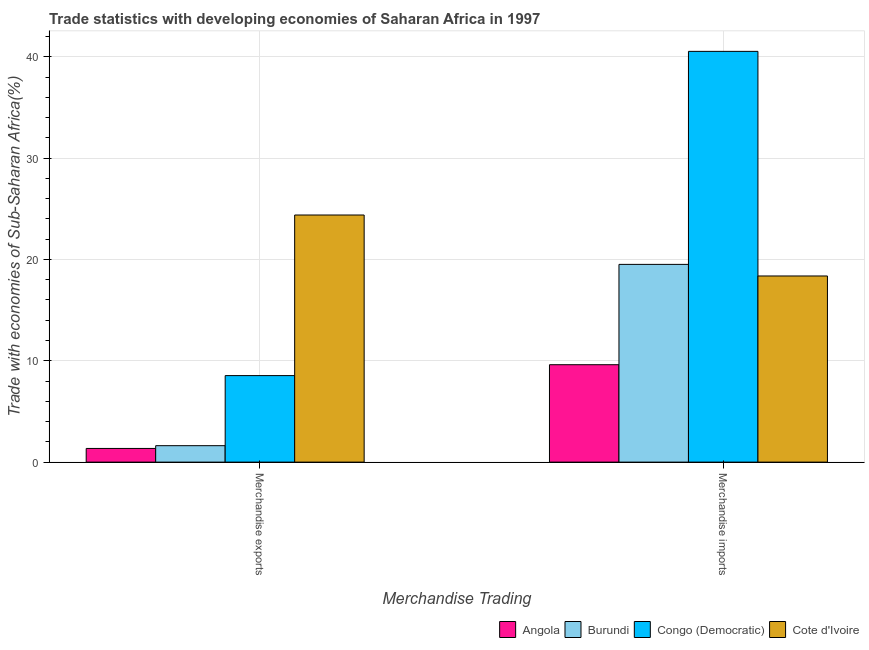How many different coloured bars are there?
Your answer should be very brief. 4. Are the number of bars per tick equal to the number of legend labels?
Make the answer very short. Yes. Are the number of bars on each tick of the X-axis equal?
Your response must be concise. Yes. What is the merchandise exports in Angola?
Offer a very short reply. 1.35. Across all countries, what is the maximum merchandise imports?
Provide a short and direct response. 40.53. Across all countries, what is the minimum merchandise exports?
Keep it short and to the point. 1.35. In which country was the merchandise imports maximum?
Provide a short and direct response. Congo (Democratic). In which country was the merchandise imports minimum?
Provide a succinct answer. Angola. What is the total merchandise imports in the graph?
Your answer should be compact. 88.02. What is the difference between the merchandise imports in Congo (Democratic) and that in Angola?
Offer a very short reply. 30.92. What is the difference between the merchandise exports in Cote d'Ivoire and the merchandise imports in Congo (Democratic)?
Make the answer very short. -16.15. What is the average merchandise exports per country?
Provide a short and direct response. 8.97. What is the difference between the merchandise imports and merchandise exports in Congo (Democratic)?
Keep it short and to the point. 31.99. In how many countries, is the merchandise exports greater than 28 %?
Keep it short and to the point. 0. What is the ratio of the merchandise imports in Congo (Democratic) to that in Angola?
Your answer should be very brief. 4.22. Is the merchandise imports in Congo (Democratic) less than that in Cote d'Ivoire?
Offer a terse response. No. In how many countries, is the merchandise imports greater than the average merchandise imports taken over all countries?
Offer a terse response. 1. What does the 2nd bar from the left in Merchandise exports represents?
Keep it short and to the point. Burundi. What does the 4th bar from the right in Merchandise imports represents?
Provide a succinct answer. Angola. How many bars are there?
Provide a short and direct response. 8. How many countries are there in the graph?
Your answer should be compact. 4. Does the graph contain any zero values?
Ensure brevity in your answer.  No. Does the graph contain grids?
Make the answer very short. Yes. What is the title of the graph?
Your answer should be compact. Trade statistics with developing economies of Saharan Africa in 1997. What is the label or title of the X-axis?
Ensure brevity in your answer.  Merchandise Trading. What is the label or title of the Y-axis?
Make the answer very short. Trade with economies of Sub-Saharan Africa(%). What is the Trade with economies of Sub-Saharan Africa(%) in Angola in Merchandise exports?
Your answer should be very brief. 1.35. What is the Trade with economies of Sub-Saharan Africa(%) in Burundi in Merchandise exports?
Provide a short and direct response. 1.62. What is the Trade with economies of Sub-Saharan Africa(%) of Congo (Democratic) in Merchandise exports?
Ensure brevity in your answer.  8.54. What is the Trade with economies of Sub-Saharan Africa(%) in Cote d'Ivoire in Merchandise exports?
Provide a succinct answer. 24.38. What is the Trade with economies of Sub-Saharan Africa(%) in Angola in Merchandise imports?
Your response must be concise. 9.61. What is the Trade with economies of Sub-Saharan Africa(%) of Burundi in Merchandise imports?
Give a very brief answer. 19.51. What is the Trade with economies of Sub-Saharan Africa(%) of Congo (Democratic) in Merchandise imports?
Offer a terse response. 40.53. What is the Trade with economies of Sub-Saharan Africa(%) of Cote d'Ivoire in Merchandise imports?
Offer a very short reply. 18.37. Across all Merchandise Trading, what is the maximum Trade with economies of Sub-Saharan Africa(%) in Angola?
Offer a very short reply. 9.61. Across all Merchandise Trading, what is the maximum Trade with economies of Sub-Saharan Africa(%) in Burundi?
Make the answer very short. 19.51. Across all Merchandise Trading, what is the maximum Trade with economies of Sub-Saharan Africa(%) of Congo (Democratic)?
Offer a very short reply. 40.53. Across all Merchandise Trading, what is the maximum Trade with economies of Sub-Saharan Africa(%) in Cote d'Ivoire?
Ensure brevity in your answer.  24.38. Across all Merchandise Trading, what is the minimum Trade with economies of Sub-Saharan Africa(%) in Angola?
Provide a short and direct response. 1.35. Across all Merchandise Trading, what is the minimum Trade with economies of Sub-Saharan Africa(%) in Burundi?
Make the answer very short. 1.62. Across all Merchandise Trading, what is the minimum Trade with economies of Sub-Saharan Africa(%) of Congo (Democratic)?
Ensure brevity in your answer.  8.54. Across all Merchandise Trading, what is the minimum Trade with economies of Sub-Saharan Africa(%) in Cote d'Ivoire?
Offer a very short reply. 18.37. What is the total Trade with economies of Sub-Saharan Africa(%) of Angola in the graph?
Your response must be concise. 10.96. What is the total Trade with economies of Sub-Saharan Africa(%) of Burundi in the graph?
Offer a very short reply. 21.13. What is the total Trade with economies of Sub-Saharan Africa(%) in Congo (Democratic) in the graph?
Provide a short and direct response. 49.07. What is the total Trade with economies of Sub-Saharan Africa(%) in Cote d'Ivoire in the graph?
Your answer should be very brief. 42.75. What is the difference between the Trade with economies of Sub-Saharan Africa(%) in Angola in Merchandise exports and that in Merchandise imports?
Ensure brevity in your answer.  -8.26. What is the difference between the Trade with economies of Sub-Saharan Africa(%) in Burundi in Merchandise exports and that in Merchandise imports?
Keep it short and to the point. -17.89. What is the difference between the Trade with economies of Sub-Saharan Africa(%) of Congo (Democratic) in Merchandise exports and that in Merchandise imports?
Your response must be concise. -31.99. What is the difference between the Trade with economies of Sub-Saharan Africa(%) of Cote d'Ivoire in Merchandise exports and that in Merchandise imports?
Offer a terse response. 6.02. What is the difference between the Trade with economies of Sub-Saharan Africa(%) in Angola in Merchandise exports and the Trade with economies of Sub-Saharan Africa(%) in Burundi in Merchandise imports?
Keep it short and to the point. -18.16. What is the difference between the Trade with economies of Sub-Saharan Africa(%) of Angola in Merchandise exports and the Trade with economies of Sub-Saharan Africa(%) of Congo (Democratic) in Merchandise imports?
Offer a very short reply. -39.18. What is the difference between the Trade with economies of Sub-Saharan Africa(%) in Angola in Merchandise exports and the Trade with economies of Sub-Saharan Africa(%) in Cote d'Ivoire in Merchandise imports?
Offer a very short reply. -17.02. What is the difference between the Trade with economies of Sub-Saharan Africa(%) of Burundi in Merchandise exports and the Trade with economies of Sub-Saharan Africa(%) of Congo (Democratic) in Merchandise imports?
Provide a succinct answer. -38.91. What is the difference between the Trade with economies of Sub-Saharan Africa(%) in Burundi in Merchandise exports and the Trade with economies of Sub-Saharan Africa(%) in Cote d'Ivoire in Merchandise imports?
Your answer should be very brief. -16.75. What is the difference between the Trade with economies of Sub-Saharan Africa(%) of Congo (Democratic) in Merchandise exports and the Trade with economies of Sub-Saharan Africa(%) of Cote d'Ivoire in Merchandise imports?
Provide a short and direct response. -9.83. What is the average Trade with economies of Sub-Saharan Africa(%) in Angola per Merchandise Trading?
Give a very brief answer. 5.48. What is the average Trade with economies of Sub-Saharan Africa(%) in Burundi per Merchandise Trading?
Give a very brief answer. 10.57. What is the average Trade with economies of Sub-Saharan Africa(%) in Congo (Democratic) per Merchandise Trading?
Make the answer very short. 24.53. What is the average Trade with economies of Sub-Saharan Africa(%) in Cote d'Ivoire per Merchandise Trading?
Provide a succinct answer. 21.38. What is the difference between the Trade with economies of Sub-Saharan Africa(%) of Angola and Trade with economies of Sub-Saharan Africa(%) of Burundi in Merchandise exports?
Your response must be concise. -0.27. What is the difference between the Trade with economies of Sub-Saharan Africa(%) in Angola and Trade with economies of Sub-Saharan Africa(%) in Congo (Democratic) in Merchandise exports?
Your answer should be compact. -7.19. What is the difference between the Trade with economies of Sub-Saharan Africa(%) of Angola and Trade with economies of Sub-Saharan Africa(%) of Cote d'Ivoire in Merchandise exports?
Keep it short and to the point. -23.04. What is the difference between the Trade with economies of Sub-Saharan Africa(%) of Burundi and Trade with economies of Sub-Saharan Africa(%) of Congo (Democratic) in Merchandise exports?
Ensure brevity in your answer.  -6.91. What is the difference between the Trade with economies of Sub-Saharan Africa(%) of Burundi and Trade with economies of Sub-Saharan Africa(%) of Cote d'Ivoire in Merchandise exports?
Make the answer very short. -22.76. What is the difference between the Trade with economies of Sub-Saharan Africa(%) in Congo (Democratic) and Trade with economies of Sub-Saharan Africa(%) in Cote d'Ivoire in Merchandise exports?
Give a very brief answer. -15.85. What is the difference between the Trade with economies of Sub-Saharan Africa(%) of Angola and Trade with economies of Sub-Saharan Africa(%) of Burundi in Merchandise imports?
Your answer should be very brief. -9.9. What is the difference between the Trade with economies of Sub-Saharan Africa(%) in Angola and Trade with economies of Sub-Saharan Africa(%) in Congo (Democratic) in Merchandise imports?
Offer a terse response. -30.92. What is the difference between the Trade with economies of Sub-Saharan Africa(%) of Angola and Trade with economies of Sub-Saharan Africa(%) of Cote d'Ivoire in Merchandise imports?
Give a very brief answer. -8.76. What is the difference between the Trade with economies of Sub-Saharan Africa(%) of Burundi and Trade with economies of Sub-Saharan Africa(%) of Congo (Democratic) in Merchandise imports?
Provide a succinct answer. -21.02. What is the difference between the Trade with economies of Sub-Saharan Africa(%) in Burundi and Trade with economies of Sub-Saharan Africa(%) in Cote d'Ivoire in Merchandise imports?
Make the answer very short. 1.14. What is the difference between the Trade with economies of Sub-Saharan Africa(%) of Congo (Democratic) and Trade with economies of Sub-Saharan Africa(%) of Cote d'Ivoire in Merchandise imports?
Offer a terse response. 22.16. What is the ratio of the Trade with economies of Sub-Saharan Africa(%) of Angola in Merchandise exports to that in Merchandise imports?
Ensure brevity in your answer.  0.14. What is the ratio of the Trade with economies of Sub-Saharan Africa(%) of Burundi in Merchandise exports to that in Merchandise imports?
Provide a short and direct response. 0.08. What is the ratio of the Trade with economies of Sub-Saharan Africa(%) of Congo (Democratic) in Merchandise exports to that in Merchandise imports?
Make the answer very short. 0.21. What is the ratio of the Trade with economies of Sub-Saharan Africa(%) of Cote d'Ivoire in Merchandise exports to that in Merchandise imports?
Keep it short and to the point. 1.33. What is the difference between the highest and the second highest Trade with economies of Sub-Saharan Africa(%) of Angola?
Make the answer very short. 8.26. What is the difference between the highest and the second highest Trade with economies of Sub-Saharan Africa(%) in Burundi?
Provide a short and direct response. 17.89. What is the difference between the highest and the second highest Trade with economies of Sub-Saharan Africa(%) of Congo (Democratic)?
Your answer should be very brief. 31.99. What is the difference between the highest and the second highest Trade with economies of Sub-Saharan Africa(%) of Cote d'Ivoire?
Give a very brief answer. 6.02. What is the difference between the highest and the lowest Trade with economies of Sub-Saharan Africa(%) of Angola?
Ensure brevity in your answer.  8.26. What is the difference between the highest and the lowest Trade with economies of Sub-Saharan Africa(%) of Burundi?
Offer a terse response. 17.89. What is the difference between the highest and the lowest Trade with economies of Sub-Saharan Africa(%) in Congo (Democratic)?
Your answer should be very brief. 31.99. What is the difference between the highest and the lowest Trade with economies of Sub-Saharan Africa(%) in Cote d'Ivoire?
Provide a succinct answer. 6.02. 